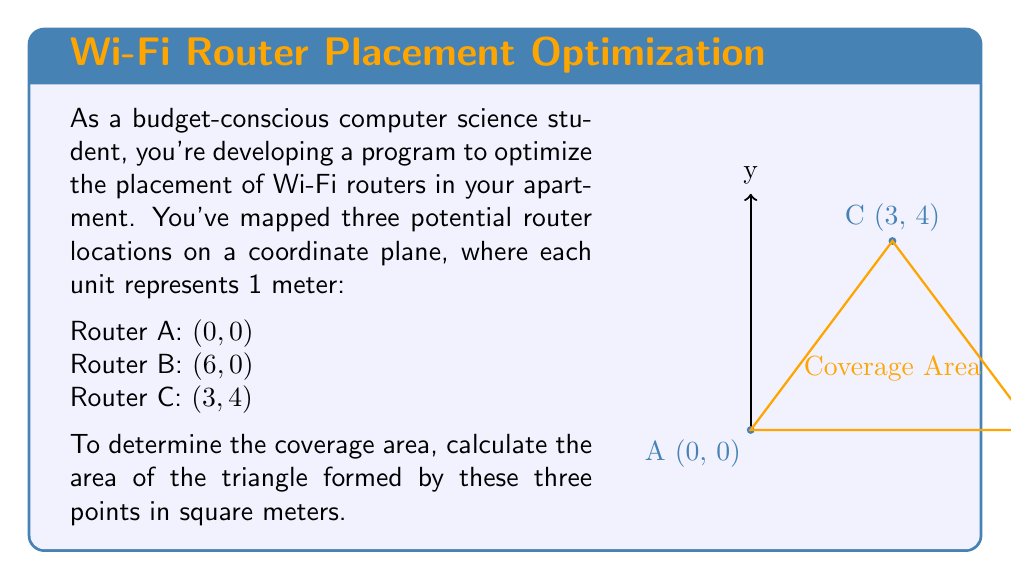Can you answer this question? To calculate the area of a triangle given three points in a coordinate plane, we can use the formula:

$$\text{Area} = \frac{1}{2}|x_1(y_2 - y_3) + x_2(y_3 - y_1) + x_3(y_1 - y_2)|$$

Where $(x_1, y_1)$, $(x_2, y_2)$, and $(x_3, y_3)$ are the coordinates of the three points.

Step 1: Identify the coordinates
A: $(x_1, y_1) = (0, 0)$
B: $(x_2, y_2) = (6, 0)$
C: $(x_3, y_3) = (3, 4)$

Step 2: Substitute the values into the formula
$$\text{Area} = \frac{1}{2}|0(0 - 4) + 6(4 - 0) + 3(0 - 0)|$$

Step 3: Simplify
$$\text{Area} = \frac{1}{2}|0 + 24 + 0|$$
$$\text{Area} = \frac{1}{2}|24|$$
$$\text{Area} = \frac{1}{2} \cdot 24$$
$$\text{Area} = 12$$

Therefore, the area of the triangle is 12 square meters.
Answer: 12 m² 